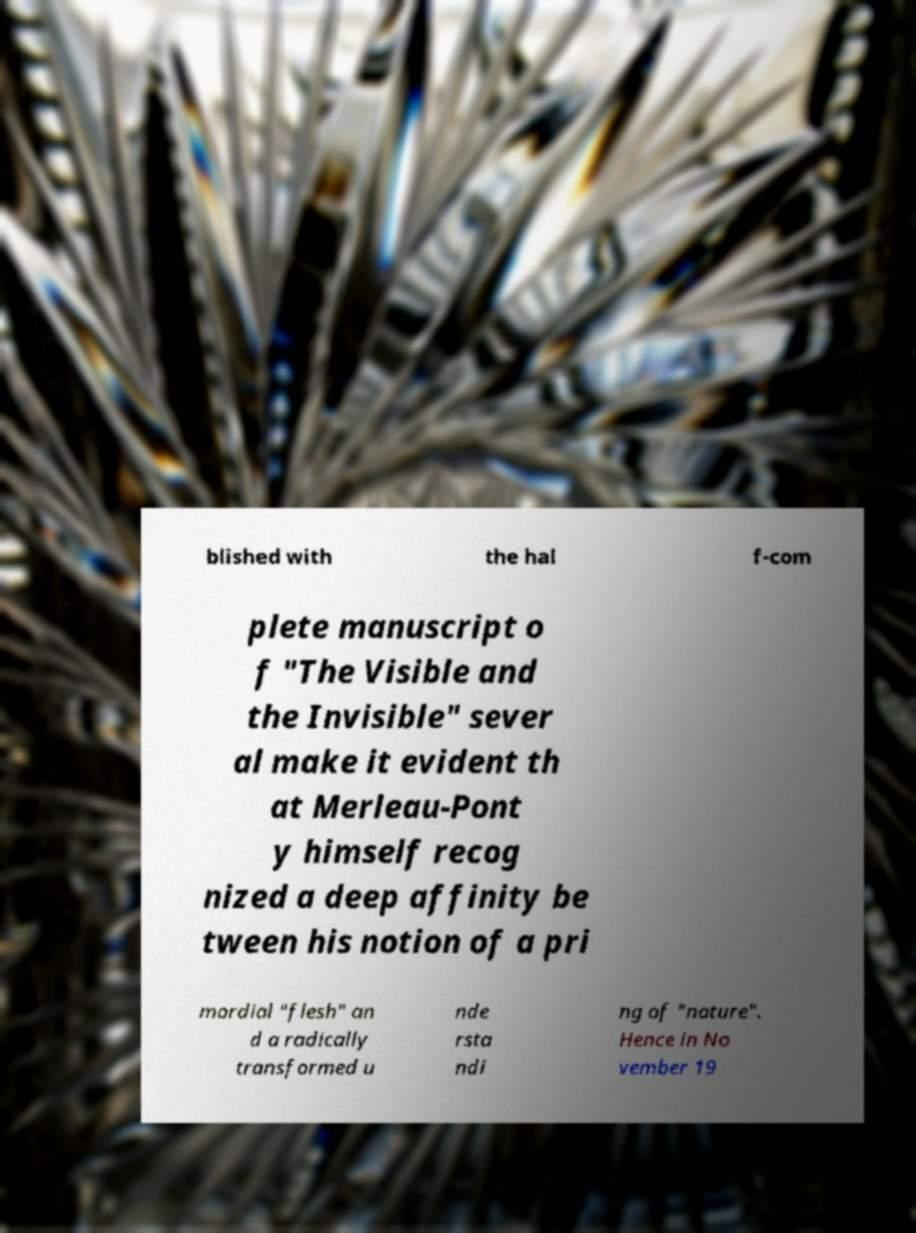Please identify and transcribe the text found in this image. blished with the hal f-com plete manuscript o f "The Visible and the Invisible" sever al make it evident th at Merleau-Pont y himself recog nized a deep affinity be tween his notion of a pri mordial "flesh" an d a radically transformed u nde rsta ndi ng of "nature". Hence in No vember 19 